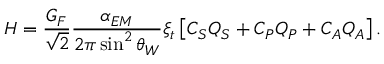<formula> <loc_0><loc_0><loc_500><loc_500>H = \frac { G _ { F } } { \sqrt { 2 } } \frac { \alpha _ { E M } } { 2 \pi \sin ^ { 2 } \theta _ { W } } \xi _ { t } \left [ C _ { S } Q _ { S } + C _ { P } Q _ { P } + C _ { A } Q _ { A } \right ] .</formula> 